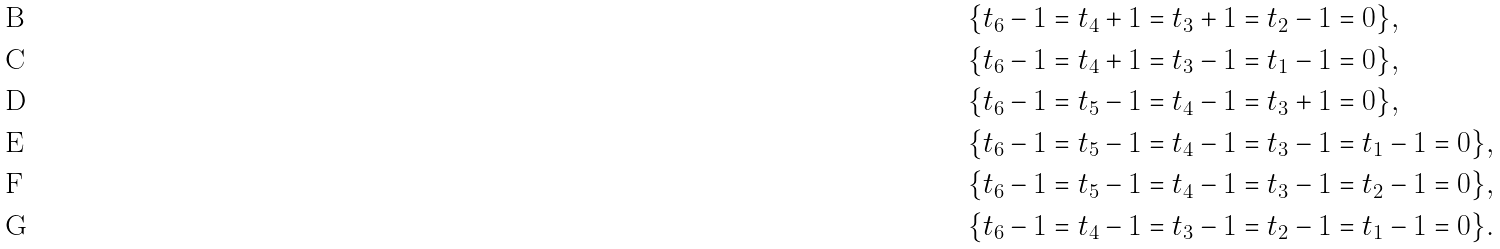<formula> <loc_0><loc_0><loc_500><loc_500>& \{ t _ { 6 } - 1 = t _ { 4 } + 1 = t _ { 3 } + 1 = t _ { 2 } - 1 = 0 \} , \\ & \{ t _ { 6 } - 1 = t _ { 4 } + 1 = t _ { 3 } - 1 = t _ { 1 } - 1 = 0 \} , \\ & \{ t _ { 6 } - 1 = t _ { 5 } - 1 = t _ { 4 } - 1 = t _ { 3 } + 1 = 0 \} , \\ & \{ t _ { 6 } - 1 = t _ { 5 } - 1 = t _ { 4 } - 1 = t _ { 3 } - 1 = t _ { 1 } - 1 = 0 \} , \\ & \{ t _ { 6 } - 1 = t _ { 5 } - 1 = t _ { 4 } - 1 = t _ { 3 } - 1 = t _ { 2 } - 1 = 0 \} , \\ & \{ t _ { 6 } - 1 = t _ { 4 } - 1 = t _ { 3 } - 1 = t _ { 2 } - 1 = t _ { 1 } - 1 = 0 \} .</formula> 